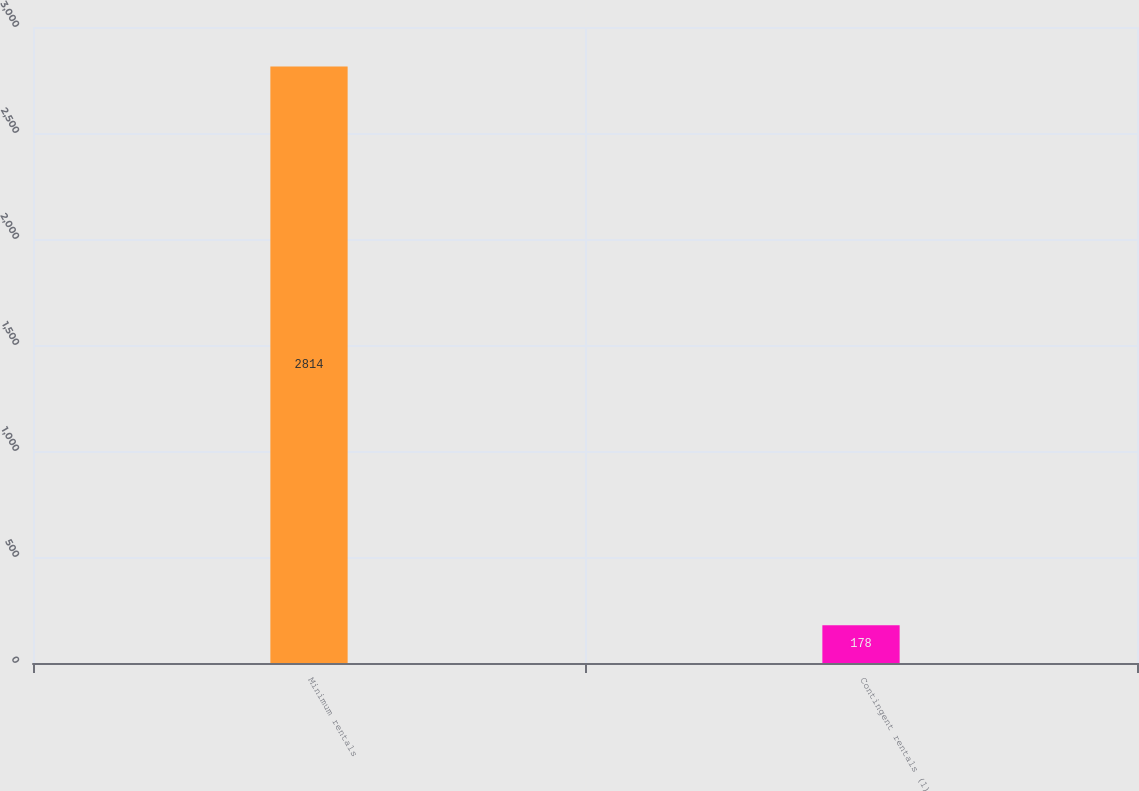<chart> <loc_0><loc_0><loc_500><loc_500><bar_chart><fcel>Minimum rentals<fcel>Contingent rentals (1)<nl><fcel>2814<fcel>178<nl></chart> 